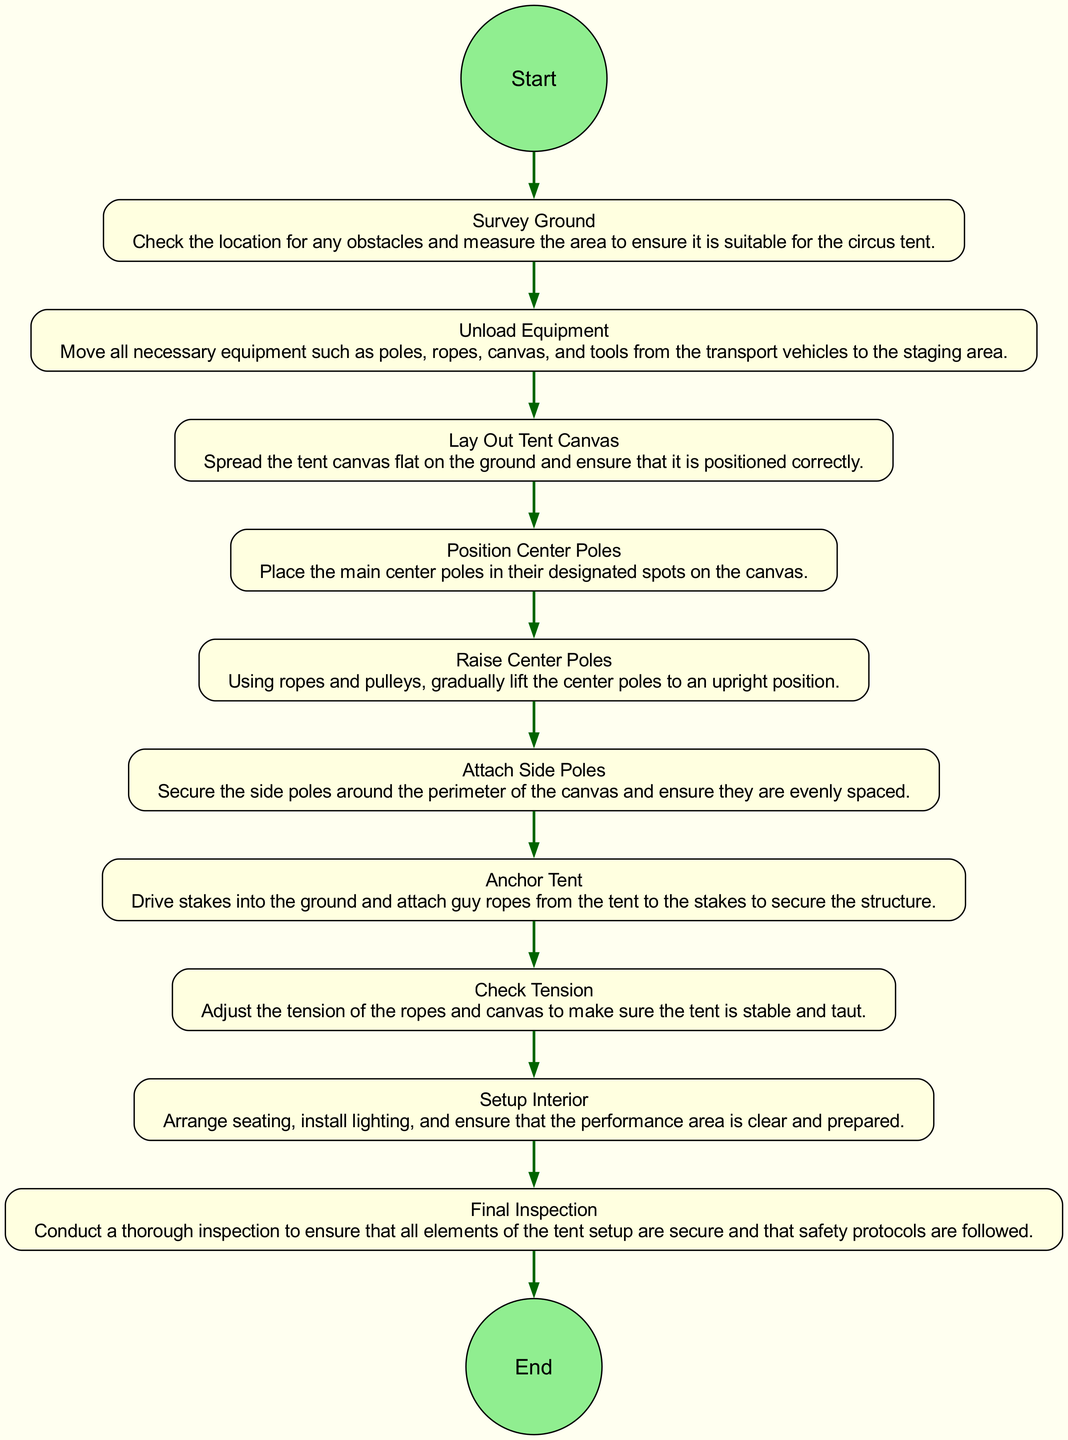What is the first activity listed in the diagram? The first activity in the diagram sequences is "Survey Ground," which is the starting point before any other activities take place.
Answer: Survey Ground How many total activities are there in this setup process? By counting the activities listed in the diagram, there are a total of ten distinct activities that describe the tent setup process.
Answer: 10 What is the last activity before the final inspection? The last activity before this step is "Setup Interior," which involves arranging seating and preparing the performance area before conducting the final inspection.
Answer: Setup Interior Which activity comes directly after "Raise Center Poles"? The activity that follows "Raise Center Poles" is "Attach Side Poles,” indicating that side poles are to be secured right after the center poles are raised.
Answer: Attach Side Poles What activity involves adjusting the ropes and canvas tension? The activity labeled "Check Tension" specifically includes the adjustment of the ropes and canvas tension to ensure stability and tautness of the tent.
Answer: Check Tension How are the activities related to one another? The activities are sequentially linked, showing a clear progression from surveying the ground to the final inspection, with each step relying on the completion of the previous one, indicating a flow of actions required for setup.
Answer: Sequentially linked What two activities are involved in securing the tent? The activities involved in this process are "Anchor Tent," which includes driving stakes and attaching guy ropes, and "Check Tension," which ensures the tent remains securely in place.
Answer: Anchor Tent and Check Tension How are the start and end of the process represented in the diagram? The start is shown as a "Start" node, leading to the first activity, and the end is indicated by an "End" node, following the last activity, forming a clear start-to-finish visual representation.
Answer: Start and End nodes 